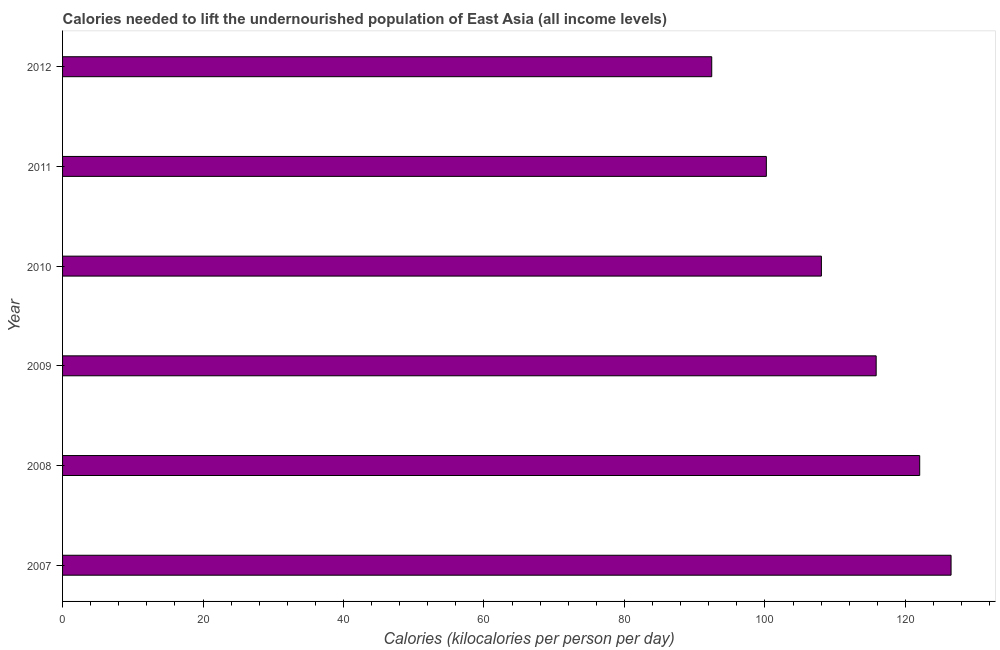Does the graph contain any zero values?
Offer a very short reply. No. What is the title of the graph?
Offer a terse response. Calories needed to lift the undernourished population of East Asia (all income levels). What is the label or title of the X-axis?
Give a very brief answer. Calories (kilocalories per person per day). What is the label or title of the Y-axis?
Make the answer very short. Year. What is the depth of food deficit in 2010?
Keep it short and to the point. 108.04. Across all years, what is the maximum depth of food deficit?
Offer a terse response. 126.5. Across all years, what is the minimum depth of food deficit?
Your answer should be compact. 92.43. In which year was the depth of food deficit maximum?
Give a very brief answer. 2007. In which year was the depth of food deficit minimum?
Offer a very short reply. 2012. What is the sum of the depth of food deficit?
Offer a very short reply. 665.04. What is the difference between the depth of food deficit in 2011 and 2012?
Offer a terse response. 7.78. What is the average depth of food deficit per year?
Your response must be concise. 110.84. What is the median depth of food deficit?
Provide a succinct answer. 111.94. Do a majority of the years between 2009 and 2012 (inclusive) have depth of food deficit greater than 24 kilocalories?
Ensure brevity in your answer.  Yes. What is the ratio of the depth of food deficit in 2007 to that in 2009?
Offer a very short reply. 1.09. What is the difference between the highest and the second highest depth of food deficit?
Provide a short and direct response. 4.47. What is the difference between the highest and the lowest depth of food deficit?
Make the answer very short. 34.08. Are all the bars in the graph horizontal?
Offer a terse response. Yes. What is the difference between two consecutive major ticks on the X-axis?
Make the answer very short. 20. What is the Calories (kilocalories per person per day) in 2007?
Make the answer very short. 126.5. What is the Calories (kilocalories per person per day) in 2008?
Offer a terse response. 122.04. What is the Calories (kilocalories per person per day) of 2009?
Offer a terse response. 115.84. What is the Calories (kilocalories per person per day) of 2010?
Your response must be concise. 108.04. What is the Calories (kilocalories per person per day) in 2011?
Keep it short and to the point. 100.2. What is the Calories (kilocalories per person per day) of 2012?
Your answer should be very brief. 92.43. What is the difference between the Calories (kilocalories per person per day) in 2007 and 2008?
Offer a very short reply. 4.47. What is the difference between the Calories (kilocalories per person per day) in 2007 and 2009?
Keep it short and to the point. 10.66. What is the difference between the Calories (kilocalories per person per day) in 2007 and 2010?
Offer a terse response. 18.46. What is the difference between the Calories (kilocalories per person per day) in 2007 and 2011?
Provide a short and direct response. 26.3. What is the difference between the Calories (kilocalories per person per day) in 2007 and 2012?
Ensure brevity in your answer.  34.08. What is the difference between the Calories (kilocalories per person per day) in 2008 and 2009?
Make the answer very short. 6.2. What is the difference between the Calories (kilocalories per person per day) in 2008 and 2010?
Keep it short and to the point. 14. What is the difference between the Calories (kilocalories per person per day) in 2008 and 2011?
Keep it short and to the point. 21.83. What is the difference between the Calories (kilocalories per person per day) in 2008 and 2012?
Make the answer very short. 29.61. What is the difference between the Calories (kilocalories per person per day) in 2009 and 2010?
Keep it short and to the point. 7.8. What is the difference between the Calories (kilocalories per person per day) in 2009 and 2011?
Ensure brevity in your answer.  15.64. What is the difference between the Calories (kilocalories per person per day) in 2009 and 2012?
Your answer should be very brief. 23.41. What is the difference between the Calories (kilocalories per person per day) in 2010 and 2011?
Offer a very short reply. 7.84. What is the difference between the Calories (kilocalories per person per day) in 2010 and 2012?
Give a very brief answer. 15.61. What is the difference between the Calories (kilocalories per person per day) in 2011 and 2012?
Your answer should be very brief. 7.78. What is the ratio of the Calories (kilocalories per person per day) in 2007 to that in 2009?
Your response must be concise. 1.09. What is the ratio of the Calories (kilocalories per person per day) in 2007 to that in 2010?
Your answer should be very brief. 1.17. What is the ratio of the Calories (kilocalories per person per day) in 2007 to that in 2011?
Provide a short and direct response. 1.26. What is the ratio of the Calories (kilocalories per person per day) in 2007 to that in 2012?
Give a very brief answer. 1.37. What is the ratio of the Calories (kilocalories per person per day) in 2008 to that in 2009?
Offer a very short reply. 1.05. What is the ratio of the Calories (kilocalories per person per day) in 2008 to that in 2010?
Provide a succinct answer. 1.13. What is the ratio of the Calories (kilocalories per person per day) in 2008 to that in 2011?
Make the answer very short. 1.22. What is the ratio of the Calories (kilocalories per person per day) in 2008 to that in 2012?
Offer a terse response. 1.32. What is the ratio of the Calories (kilocalories per person per day) in 2009 to that in 2010?
Your answer should be very brief. 1.07. What is the ratio of the Calories (kilocalories per person per day) in 2009 to that in 2011?
Ensure brevity in your answer.  1.16. What is the ratio of the Calories (kilocalories per person per day) in 2009 to that in 2012?
Ensure brevity in your answer.  1.25. What is the ratio of the Calories (kilocalories per person per day) in 2010 to that in 2011?
Make the answer very short. 1.08. What is the ratio of the Calories (kilocalories per person per day) in 2010 to that in 2012?
Make the answer very short. 1.17. What is the ratio of the Calories (kilocalories per person per day) in 2011 to that in 2012?
Your answer should be very brief. 1.08. 